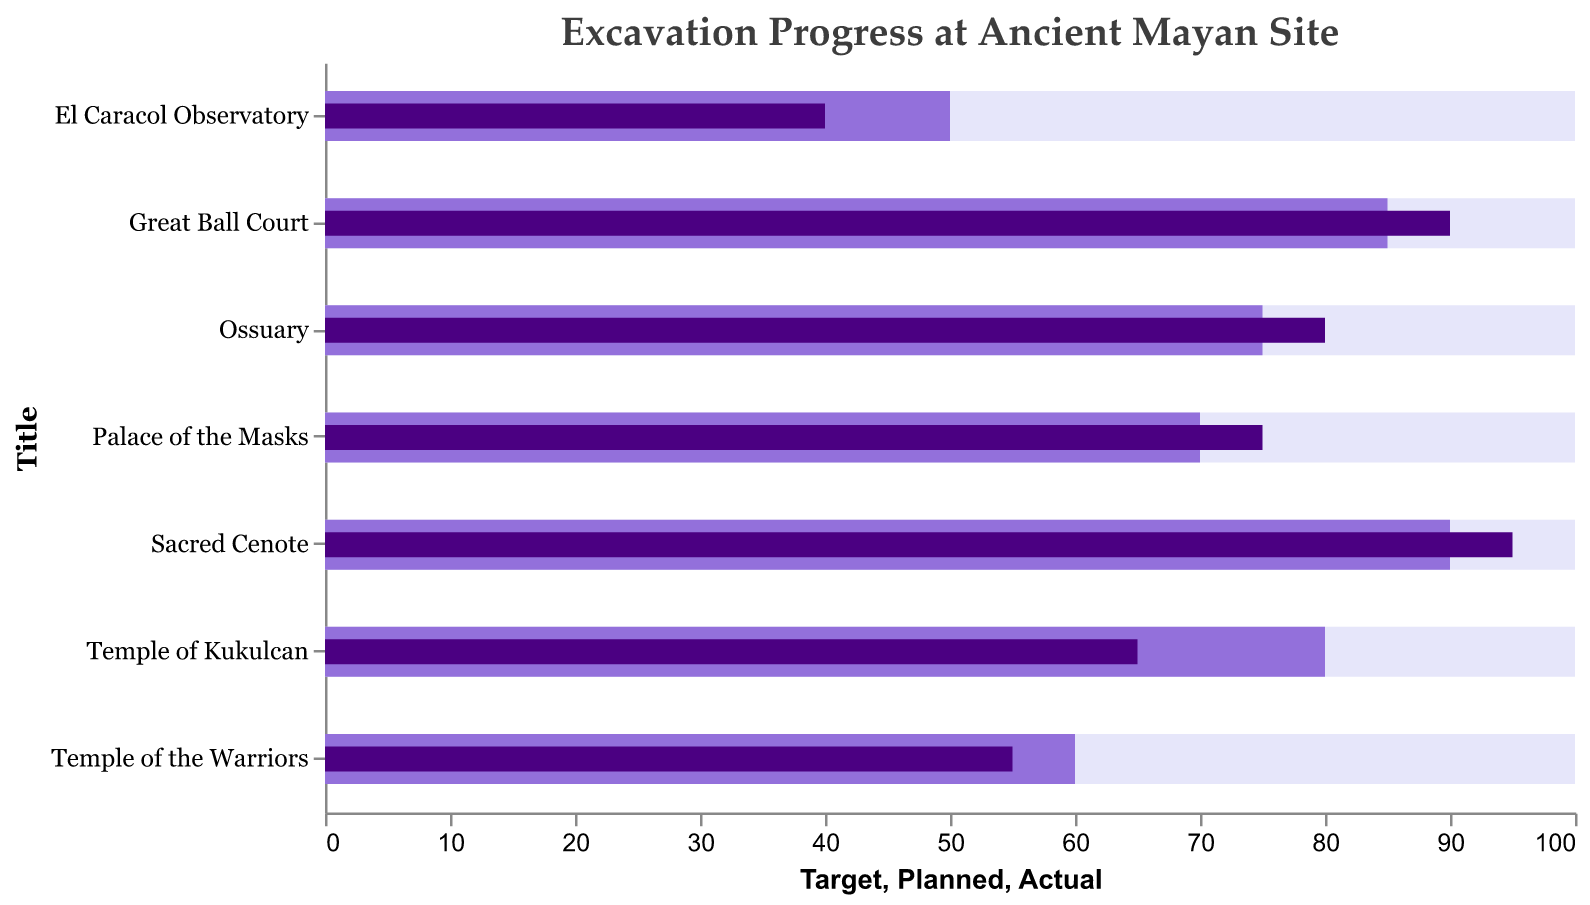Which site has the highest actual excavation progress? Look at the "Actual" values for each site and find the highest percentage. Compare all values and identify the maximum.
Answer: Sacred Cenote What is the difference in planned and actual progress for the Temple of Kukulcan? For the Temple of Kukulcan, subtract the Actual value from the Planned value (80 - 65).
Answer: 15 Which sites have actual progress greater than the planned progress? Compare the "Actual" percentages to the "Planned" percentages for each site. Identify sites where Actual > Planned.
Answer: Great Ball Court, Palace of the Masks, Sacred Cenote, Ossuary What is the average actual progress across all sites? Sum all "Actual" values and divide by the number of sites (65 + 90 + 40 + 75 + 95 + 80 + 55) / 7.
Answer: 71.4 Which site shows the largest discrepancy between planned and actual progress? Calculate the absolute difference between "Planned" and "Actual" for each site. Identify the largest difference.
Answer: Temple of Kukulcan What title is given to this bullet chart? Read the title text displayed at the top of the chart.
Answer: Excavation Progress at Ancient Mayan Site Which site is closest to its planned progress? Compare the planned vs actual percentages for each site and find the smallest absolute difference.
Answer: Ossuary What are the targets for completion of all sites? Targets are all listed as 100 for every site, confirm this by referencing the "Target" values.
Answer: 100 for all How far is the actual excavation of El Caracol Observatory from the target? Subtract the Actual value of El Caracol Observatory from the Target (100 - 40).
Answer: 60 